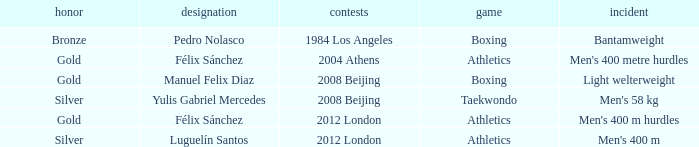Which Sport had an Event of men's 400 m hurdles? Athletics. 